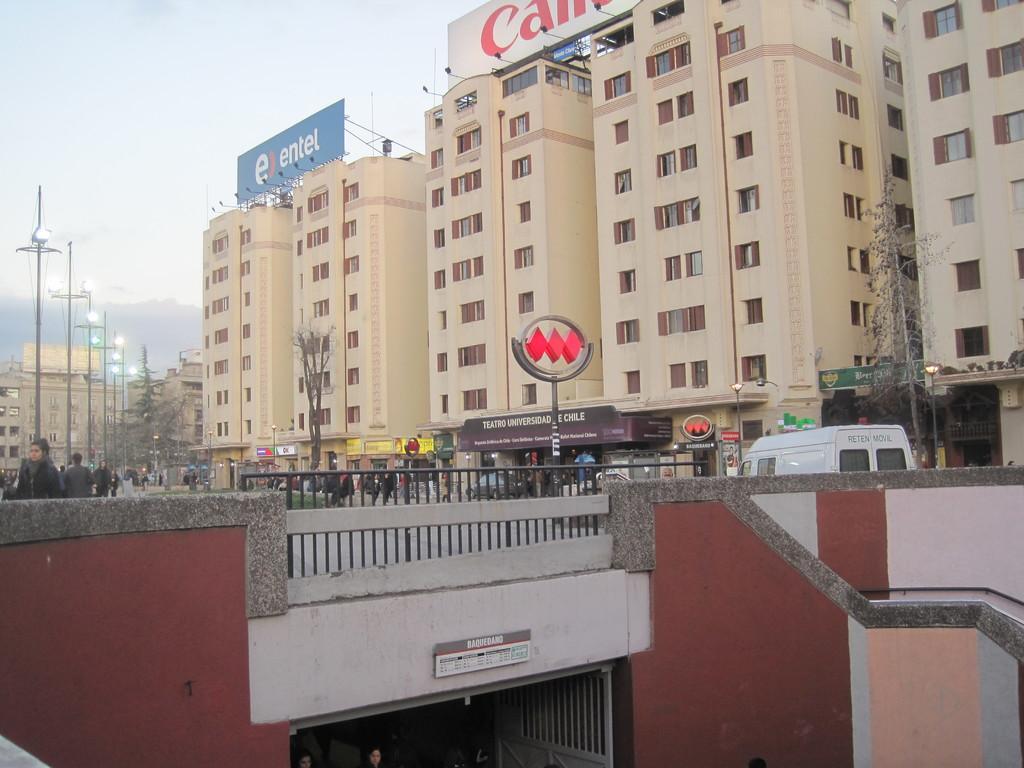Could you give a brief overview of what you see in this image? As we can see in the image there is bridge, fence, dry trees, sign pole, few people, street lamps, banners, buildings and at the top there is sky. 